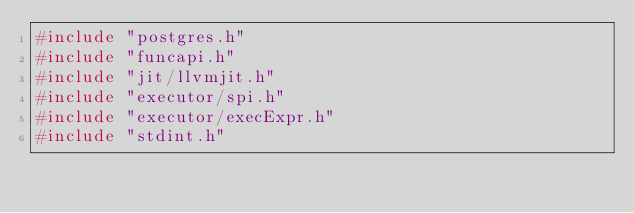<code> <loc_0><loc_0><loc_500><loc_500><_C_>#include "postgres.h"
#include "funcapi.h"
#include "jit/llvmjit.h"
#include "executor/spi.h"
#include "executor/execExpr.h"
#include "stdint.h"</code> 